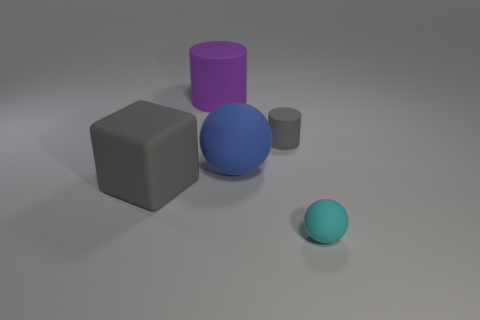Is the cyan object the same shape as the small gray rubber thing?
Give a very brief answer. No. There is a gray matte thing that is on the right side of the big cylinder to the left of the tiny rubber object behind the small cyan rubber object; what size is it?
Give a very brief answer. Small. What is the material of the other thing that is the same shape as the large purple object?
Your answer should be very brief. Rubber. Is there any other thing that has the same size as the rubber block?
Your answer should be very brief. Yes. How big is the gray object that is left of the tiny object left of the tiny cyan matte sphere?
Your answer should be very brief. Large. What is the color of the large block?
Offer a very short reply. Gray. How many cyan rubber balls are left of the sphere that is on the left side of the cyan matte sphere?
Provide a succinct answer. 0. There is a gray thing that is in front of the large blue matte thing; are there any big purple things behind it?
Give a very brief answer. Yes. There is a block; are there any tiny cyan objects on the left side of it?
Your answer should be very brief. No. Is the shape of the gray object right of the large gray thing the same as  the big gray object?
Ensure brevity in your answer.  No. 